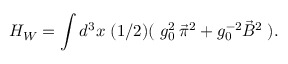<formula> <loc_0><loc_0><loc_500><loc_500>H _ { W } = \int d ^ { 3 } x \, ( 1 / 2 ) ( \, g _ { 0 } ^ { 2 } \, \vec { \pi } ^ { 2 } + g _ { 0 } ^ { - 2 } \vec { B } ^ { 2 } \, ) .</formula> 